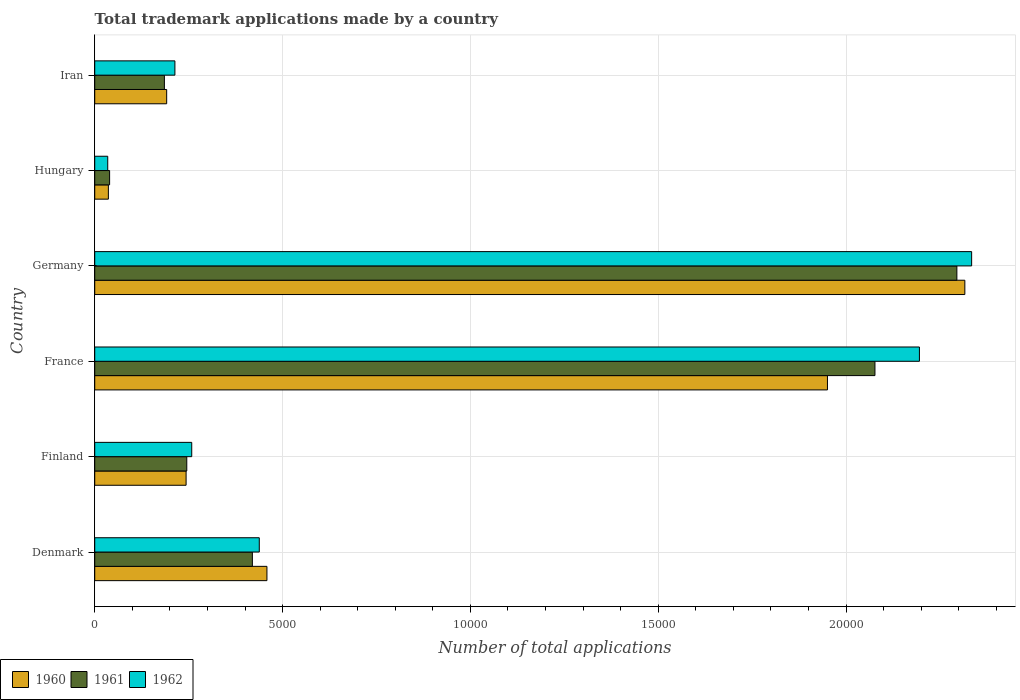How many different coloured bars are there?
Provide a short and direct response. 3. How many groups of bars are there?
Your answer should be compact. 6. Are the number of bars per tick equal to the number of legend labels?
Ensure brevity in your answer.  Yes. Are the number of bars on each tick of the Y-axis equal?
Give a very brief answer. Yes. How many bars are there on the 4th tick from the top?
Your response must be concise. 3. What is the label of the 2nd group of bars from the top?
Give a very brief answer. Hungary. In how many cases, is the number of bars for a given country not equal to the number of legend labels?
Keep it short and to the point. 0. What is the number of applications made by in 1962 in Denmark?
Your answer should be compact. 4380. Across all countries, what is the maximum number of applications made by in 1961?
Your response must be concise. 2.29e+04. Across all countries, what is the minimum number of applications made by in 1960?
Ensure brevity in your answer.  363. In which country was the number of applications made by in 1961 maximum?
Provide a short and direct response. Germany. In which country was the number of applications made by in 1960 minimum?
Keep it short and to the point. Hungary. What is the total number of applications made by in 1961 in the graph?
Provide a succinct answer. 5.26e+04. What is the difference between the number of applications made by in 1960 in Denmark and that in Hungary?
Your answer should be compact. 4221. What is the difference between the number of applications made by in 1961 in Denmark and the number of applications made by in 1962 in Iran?
Provide a succinct answer. 2062. What is the average number of applications made by in 1961 per country?
Make the answer very short. 8768.83. What is the difference between the number of applications made by in 1962 and number of applications made by in 1960 in Iran?
Give a very brief answer. 219. In how many countries, is the number of applications made by in 1961 greater than 19000 ?
Offer a very short reply. 2. What is the ratio of the number of applications made by in 1962 in France to that in Iran?
Keep it short and to the point. 10.29. Is the difference between the number of applications made by in 1962 in France and Iran greater than the difference between the number of applications made by in 1960 in France and Iran?
Give a very brief answer. Yes. What is the difference between the highest and the second highest number of applications made by in 1960?
Your answer should be compact. 3657. What is the difference between the highest and the lowest number of applications made by in 1962?
Keep it short and to the point. 2.30e+04. Is the sum of the number of applications made by in 1962 in France and Hungary greater than the maximum number of applications made by in 1961 across all countries?
Keep it short and to the point. No. What does the 2nd bar from the top in Iran represents?
Your response must be concise. 1961. Are all the bars in the graph horizontal?
Provide a short and direct response. Yes. How many countries are there in the graph?
Keep it short and to the point. 6. What is the difference between two consecutive major ticks on the X-axis?
Your answer should be compact. 5000. Are the values on the major ticks of X-axis written in scientific E-notation?
Keep it short and to the point. No. Does the graph contain grids?
Provide a short and direct response. Yes. How are the legend labels stacked?
Provide a short and direct response. Horizontal. What is the title of the graph?
Provide a succinct answer. Total trademark applications made by a country. Does "2007" appear as one of the legend labels in the graph?
Your answer should be very brief. No. What is the label or title of the X-axis?
Make the answer very short. Number of total applications. What is the Number of total applications in 1960 in Denmark?
Keep it short and to the point. 4584. What is the Number of total applications in 1961 in Denmark?
Give a very brief answer. 4196. What is the Number of total applications in 1962 in Denmark?
Make the answer very short. 4380. What is the Number of total applications in 1960 in Finland?
Offer a terse response. 2432. What is the Number of total applications of 1961 in Finland?
Your response must be concise. 2450. What is the Number of total applications in 1962 in Finland?
Ensure brevity in your answer.  2582. What is the Number of total applications in 1960 in France?
Keep it short and to the point. 1.95e+04. What is the Number of total applications of 1961 in France?
Your answer should be compact. 2.08e+04. What is the Number of total applications in 1962 in France?
Your answer should be very brief. 2.20e+04. What is the Number of total applications in 1960 in Germany?
Keep it short and to the point. 2.32e+04. What is the Number of total applications in 1961 in Germany?
Offer a terse response. 2.29e+04. What is the Number of total applications in 1962 in Germany?
Offer a terse response. 2.33e+04. What is the Number of total applications in 1960 in Hungary?
Provide a short and direct response. 363. What is the Number of total applications in 1961 in Hungary?
Provide a succinct answer. 396. What is the Number of total applications in 1962 in Hungary?
Your response must be concise. 346. What is the Number of total applications of 1960 in Iran?
Your response must be concise. 1915. What is the Number of total applications in 1961 in Iran?
Your answer should be compact. 1854. What is the Number of total applications in 1962 in Iran?
Your response must be concise. 2134. Across all countries, what is the maximum Number of total applications of 1960?
Provide a short and direct response. 2.32e+04. Across all countries, what is the maximum Number of total applications of 1961?
Offer a terse response. 2.29e+04. Across all countries, what is the maximum Number of total applications of 1962?
Keep it short and to the point. 2.33e+04. Across all countries, what is the minimum Number of total applications in 1960?
Your response must be concise. 363. Across all countries, what is the minimum Number of total applications of 1961?
Keep it short and to the point. 396. Across all countries, what is the minimum Number of total applications in 1962?
Offer a very short reply. 346. What is the total Number of total applications in 1960 in the graph?
Offer a terse response. 5.20e+04. What is the total Number of total applications in 1961 in the graph?
Offer a very short reply. 5.26e+04. What is the total Number of total applications of 1962 in the graph?
Your response must be concise. 5.47e+04. What is the difference between the Number of total applications in 1960 in Denmark and that in Finland?
Make the answer very short. 2152. What is the difference between the Number of total applications of 1961 in Denmark and that in Finland?
Keep it short and to the point. 1746. What is the difference between the Number of total applications of 1962 in Denmark and that in Finland?
Your answer should be compact. 1798. What is the difference between the Number of total applications of 1960 in Denmark and that in France?
Your answer should be compact. -1.49e+04. What is the difference between the Number of total applications in 1961 in Denmark and that in France?
Give a very brief answer. -1.66e+04. What is the difference between the Number of total applications in 1962 in Denmark and that in France?
Offer a terse response. -1.76e+04. What is the difference between the Number of total applications in 1960 in Denmark and that in Germany?
Give a very brief answer. -1.86e+04. What is the difference between the Number of total applications in 1961 in Denmark and that in Germany?
Ensure brevity in your answer.  -1.88e+04. What is the difference between the Number of total applications of 1962 in Denmark and that in Germany?
Provide a short and direct response. -1.90e+04. What is the difference between the Number of total applications in 1960 in Denmark and that in Hungary?
Offer a very short reply. 4221. What is the difference between the Number of total applications of 1961 in Denmark and that in Hungary?
Your answer should be very brief. 3800. What is the difference between the Number of total applications in 1962 in Denmark and that in Hungary?
Your response must be concise. 4034. What is the difference between the Number of total applications of 1960 in Denmark and that in Iran?
Your answer should be very brief. 2669. What is the difference between the Number of total applications of 1961 in Denmark and that in Iran?
Keep it short and to the point. 2342. What is the difference between the Number of total applications of 1962 in Denmark and that in Iran?
Provide a short and direct response. 2246. What is the difference between the Number of total applications of 1960 in Finland and that in France?
Make the answer very short. -1.71e+04. What is the difference between the Number of total applications of 1961 in Finland and that in France?
Ensure brevity in your answer.  -1.83e+04. What is the difference between the Number of total applications in 1962 in Finland and that in France?
Make the answer very short. -1.94e+04. What is the difference between the Number of total applications in 1960 in Finland and that in Germany?
Keep it short and to the point. -2.07e+04. What is the difference between the Number of total applications of 1961 in Finland and that in Germany?
Your response must be concise. -2.05e+04. What is the difference between the Number of total applications in 1962 in Finland and that in Germany?
Provide a succinct answer. -2.08e+04. What is the difference between the Number of total applications in 1960 in Finland and that in Hungary?
Provide a succinct answer. 2069. What is the difference between the Number of total applications of 1961 in Finland and that in Hungary?
Make the answer very short. 2054. What is the difference between the Number of total applications of 1962 in Finland and that in Hungary?
Make the answer very short. 2236. What is the difference between the Number of total applications of 1960 in Finland and that in Iran?
Make the answer very short. 517. What is the difference between the Number of total applications in 1961 in Finland and that in Iran?
Offer a very short reply. 596. What is the difference between the Number of total applications of 1962 in Finland and that in Iran?
Keep it short and to the point. 448. What is the difference between the Number of total applications in 1960 in France and that in Germany?
Give a very brief answer. -3657. What is the difference between the Number of total applications in 1961 in France and that in Germany?
Provide a short and direct response. -2181. What is the difference between the Number of total applications in 1962 in France and that in Germany?
Keep it short and to the point. -1390. What is the difference between the Number of total applications of 1960 in France and that in Hungary?
Offer a very short reply. 1.91e+04. What is the difference between the Number of total applications in 1961 in France and that in Hungary?
Your answer should be very brief. 2.04e+04. What is the difference between the Number of total applications of 1962 in France and that in Hungary?
Make the answer very short. 2.16e+04. What is the difference between the Number of total applications of 1960 in France and that in Iran?
Ensure brevity in your answer.  1.76e+04. What is the difference between the Number of total applications of 1961 in France and that in Iran?
Your response must be concise. 1.89e+04. What is the difference between the Number of total applications of 1962 in France and that in Iran?
Your response must be concise. 1.98e+04. What is the difference between the Number of total applications of 1960 in Germany and that in Hungary?
Make the answer very short. 2.28e+04. What is the difference between the Number of total applications of 1961 in Germany and that in Hungary?
Your answer should be compact. 2.26e+04. What is the difference between the Number of total applications in 1962 in Germany and that in Hungary?
Keep it short and to the point. 2.30e+04. What is the difference between the Number of total applications of 1960 in Germany and that in Iran?
Keep it short and to the point. 2.12e+04. What is the difference between the Number of total applications of 1961 in Germany and that in Iran?
Offer a terse response. 2.11e+04. What is the difference between the Number of total applications in 1962 in Germany and that in Iran?
Offer a terse response. 2.12e+04. What is the difference between the Number of total applications of 1960 in Hungary and that in Iran?
Keep it short and to the point. -1552. What is the difference between the Number of total applications of 1961 in Hungary and that in Iran?
Your answer should be compact. -1458. What is the difference between the Number of total applications in 1962 in Hungary and that in Iran?
Your response must be concise. -1788. What is the difference between the Number of total applications in 1960 in Denmark and the Number of total applications in 1961 in Finland?
Offer a very short reply. 2134. What is the difference between the Number of total applications in 1960 in Denmark and the Number of total applications in 1962 in Finland?
Make the answer very short. 2002. What is the difference between the Number of total applications in 1961 in Denmark and the Number of total applications in 1962 in Finland?
Make the answer very short. 1614. What is the difference between the Number of total applications in 1960 in Denmark and the Number of total applications in 1961 in France?
Ensure brevity in your answer.  -1.62e+04. What is the difference between the Number of total applications of 1960 in Denmark and the Number of total applications of 1962 in France?
Offer a very short reply. -1.74e+04. What is the difference between the Number of total applications in 1961 in Denmark and the Number of total applications in 1962 in France?
Your response must be concise. -1.78e+04. What is the difference between the Number of total applications of 1960 in Denmark and the Number of total applications of 1961 in Germany?
Ensure brevity in your answer.  -1.84e+04. What is the difference between the Number of total applications of 1960 in Denmark and the Number of total applications of 1962 in Germany?
Your answer should be very brief. -1.88e+04. What is the difference between the Number of total applications of 1961 in Denmark and the Number of total applications of 1962 in Germany?
Provide a succinct answer. -1.91e+04. What is the difference between the Number of total applications of 1960 in Denmark and the Number of total applications of 1961 in Hungary?
Provide a succinct answer. 4188. What is the difference between the Number of total applications in 1960 in Denmark and the Number of total applications in 1962 in Hungary?
Your response must be concise. 4238. What is the difference between the Number of total applications of 1961 in Denmark and the Number of total applications of 1962 in Hungary?
Ensure brevity in your answer.  3850. What is the difference between the Number of total applications of 1960 in Denmark and the Number of total applications of 1961 in Iran?
Offer a terse response. 2730. What is the difference between the Number of total applications of 1960 in Denmark and the Number of total applications of 1962 in Iran?
Your answer should be compact. 2450. What is the difference between the Number of total applications in 1961 in Denmark and the Number of total applications in 1962 in Iran?
Provide a short and direct response. 2062. What is the difference between the Number of total applications in 1960 in Finland and the Number of total applications in 1961 in France?
Your answer should be very brief. -1.83e+04. What is the difference between the Number of total applications of 1960 in Finland and the Number of total applications of 1962 in France?
Your answer should be compact. -1.95e+04. What is the difference between the Number of total applications in 1961 in Finland and the Number of total applications in 1962 in France?
Offer a terse response. -1.95e+04. What is the difference between the Number of total applications in 1960 in Finland and the Number of total applications in 1961 in Germany?
Offer a terse response. -2.05e+04. What is the difference between the Number of total applications in 1960 in Finland and the Number of total applications in 1962 in Germany?
Provide a succinct answer. -2.09e+04. What is the difference between the Number of total applications in 1961 in Finland and the Number of total applications in 1962 in Germany?
Make the answer very short. -2.09e+04. What is the difference between the Number of total applications in 1960 in Finland and the Number of total applications in 1961 in Hungary?
Offer a very short reply. 2036. What is the difference between the Number of total applications in 1960 in Finland and the Number of total applications in 1962 in Hungary?
Give a very brief answer. 2086. What is the difference between the Number of total applications of 1961 in Finland and the Number of total applications of 1962 in Hungary?
Provide a succinct answer. 2104. What is the difference between the Number of total applications of 1960 in Finland and the Number of total applications of 1961 in Iran?
Offer a very short reply. 578. What is the difference between the Number of total applications in 1960 in Finland and the Number of total applications in 1962 in Iran?
Your response must be concise. 298. What is the difference between the Number of total applications in 1961 in Finland and the Number of total applications in 1962 in Iran?
Offer a terse response. 316. What is the difference between the Number of total applications of 1960 in France and the Number of total applications of 1961 in Germany?
Offer a terse response. -3445. What is the difference between the Number of total applications in 1960 in France and the Number of total applications in 1962 in Germany?
Keep it short and to the point. -3838. What is the difference between the Number of total applications in 1961 in France and the Number of total applications in 1962 in Germany?
Give a very brief answer. -2574. What is the difference between the Number of total applications in 1960 in France and the Number of total applications in 1961 in Hungary?
Offer a very short reply. 1.91e+04. What is the difference between the Number of total applications of 1960 in France and the Number of total applications of 1962 in Hungary?
Your response must be concise. 1.92e+04. What is the difference between the Number of total applications of 1961 in France and the Number of total applications of 1962 in Hungary?
Offer a very short reply. 2.04e+04. What is the difference between the Number of total applications in 1960 in France and the Number of total applications in 1961 in Iran?
Make the answer very short. 1.76e+04. What is the difference between the Number of total applications in 1960 in France and the Number of total applications in 1962 in Iran?
Keep it short and to the point. 1.74e+04. What is the difference between the Number of total applications of 1961 in France and the Number of total applications of 1962 in Iran?
Give a very brief answer. 1.86e+04. What is the difference between the Number of total applications of 1960 in Germany and the Number of total applications of 1961 in Hungary?
Provide a short and direct response. 2.28e+04. What is the difference between the Number of total applications of 1960 in Germany and the Number of total applications of 1962 in Hungary?
Your response must be concise. 2.28e+04. What is the difference between the Number of total applications in 1961 in Germany and the Number of total applications in 1962 in Hungary?
Provide a short and direct response. 2.26e+04. What is the difference between the Number of total applications of 1960 in Germany and the Number of total applications of 1961 in Iran?
Your answer should be compact. 2.13e+04. What is the difference between the Number of total applications of 1960 in Germany and the Number of total applications of 1962 in Iran?
Provide a short and direct response. 2.10e+04. What is the difference between the Number of total applications of 1961 in Germany and the Number of total applications of 1962 in Iran?
Your answer should be compact. 2.08e+04. What is the difference between the Number of total applications in 1960 in Hungary and the Number of total applications in 1961 in Iran?
Provide a succinct answer. -1491. What is the difference between the Number of total applications of 1960 in Hungary and the Number of total applications of 1962 in Iran?
Provide a short and direct response. -1771. What is the difference between the Number of total applications of 1961 in Hungary and the Number of total applications of 1962 in Iran?
Provide a succinct answer. -1738. What is the average Number of total applications in 1960 per country?
Your answer should be very brief. 8659.83. What is the average Number of total applications of 1961 per country?
Provide a short and direct response. 8768.83. What is the average Number of total applications in 1962 per country?
Give a very brief answer. 9122.67. What is the difference between the Number of total applications in 1960 and Number of total applications in 1961 in Denmark?
Offer a terse response. 388. What is the difference between the Number of total applications of 1960 and Number of total applications of 1962 in Denmark?
Your response must be concise. 204. What is the difference between the Number of total applications in 1961 and Number of total applications in 1962 in Denmark?
Offer a very short reply. -184. What is the difference between the Number of total applications of 1960 and Number of total applications of 1962 in Finland?
Your answer should be very brief. -150. What is the difference between the Number of total applications of 1961 and Number of total applications of 1962 in Finland?
Offer a terse response. -132. What is the difference between the Number of total applications of 1960 and Number of total applications of 1961 in France?
Your answer should be very brief. -1264. What is the difference between the Number of total applications of 1960 and Number of total applications of 1962 in France?
Your response must be concise. -2448. What is the difference between the Number of total applications in 1961 and Number of total applications in 1962 in France?
Offer a very short reply. -1184. What is the difference between the Number of total applications in 1960 and Number of total applications in 1961 in Germany?
Ensure brevity in your answer.  212. What is the difference between the Number of total applications in 1960 and Number of total applications in 1962 in Germany?
Give a very brief answer. -181. What is the difference between the Number of total applications of 1961 and Number of total applications of 1962 in Germany?
Provide a succinct answer. -393. What is the difference between the Number of total applications in 1960 and Number of total applications in 1961 in Hungary?
Offer a very short reply. -33. What is the difference between the Number of total applications of 1960 and Number of total applications of 1962 in Iran?
Your response must be concise. -219. What is the difference between the Number of total applications in 1961 and Number of total applications in 1962 in Iran?
Make the answer very short. -280. What is the ratio of the Number of total applications of 1960 in Denmark to that in Finland?
Keep it short and to the point. 1.88. What is the ratio of the Number of total applications in 1961 in Denmark to that in Finland?
Offer a very short reply. 1.71. What is the ratio of the Number of total applications in 1962 in Denmark to that in Finland?
Offer a very short reply. 1.7. What is the ratio of the Number of total applications in 1960 in Denmark to that in France?
Ensure brevity in your answer.  0.23. What is the ratio of the Number of total applications in 1961 in Denmark to that in France?
Your answer should be compact. 0.2. What is the ratio of the Number of total applications in 1962 in Denmark to that in France?
Offer a very short reply. 0.2. What is the ratio of the Number of total applications of 1960 in Denmark to that in Germany?
Provide a succinct answer. 0.2. What is the ratio of the Number of total applications in 1961 in Denmark to that in Germany?
Offer a terse response. 0.18. What is the ratio of the Number of total applications of 1962 in Denmark to that in Germany?
Your answer should be compact. 0.19. What is the ratio of the Number of total applications of 1960 in Denmark to that in Hungary?
Offer a very short reply. 12.63. What is the ratio of the Number of total applications of 1961 in Denmark to that in Hungary?
Provide a succinct answer. 10.6. What is the ratio of the Number of total applications of 1962 in Denmark to that in Hungary?
Keep it short and to the point. 12.66. What is the ratio of the Number of total applications in 1960 in Denmark to that in Iran?
Give a very brief answer. 2.39. What is the ratio of the Number of total applications of 1961 in Denmark to that in Iran?
Keep it short and to the point. 2.26. What is the ratio of the Number of total applications in 1962 in Denmark to that in Iran?
Ensure brevity in your answer.  2.05. What is the ratio of the Number of total applications in 1960 in Finland to that in France?
Provide a succinct answer. 0.12. What is the ratio of the Number of total applications of 1961 in Finland to that in France?
Your answer should be compact. 0.12. What is the ratio of the Number of total applications of 1962 in Finland to that in France?
Make the answer very short. 0.12. What is the ratio of the Number of total applications of 1960 in Finland to that in Germany?
Offer a terse response. 0.1. What is the ratio of the Number of total applications in 1961 in Finland to that in Germany?
Ensure brevity in your answer.  0.11. What is the ratio of the Number of total applications in 1962 in Finland to that in Germany?
Provide a succinct answer. 0.11. What is the ratio of the Number of total applications of 1960 in Finland to that in Hungary?
Provide a succinct answer. 6.7. What is the ratio of the Number of total applications in 1961 in Finland to that in Hungary?
Make the answer very short. 6.19. What is the ratio of the Number of total applications in 1962 in Finland to that in Hungary?
Keep it short and to the point. 7.46. What is the ratio of the Number of total applications in 1960 in Finland to that in Iran?
Provide a succinct answer. 1.27. What is the ratio of the Number of total applications of 1961 in Finland to that in Iran?
Offer a terse response. 1.32. What is the ratio of the Number of total applications of 1962 in Finland to that in Iran?
Give a very brief answer. 1.21. What is the ratio of the Number of total applications of 1960 in France to that in Germany?
Your response must be concise. 0.84. What is the ratio of the Number of total applications of 1961 in France to that in Germany?
Offer a very short reply. 0.91. What is the ratio of the Number of total applications of 1962 in France to that in Germany?
Make the answer very short. 0.94. What is the ratio of the Number of total applications in 1960 in France to that in Hungary?
Keep it short and to the point. 53.73. What is the ratio of the Number of total applications in 1961 in France to that in Hungary?
Your answer should be very brief. 52.44. What is the ratio of the Number of total applications in 1962 in France to that in Hungary?
Offer a terse response. 63.45. What is the ratio of the Number of total applications in 1960 in France to that in Iran?
Your answer should be compact. 10.18. What is the ratio of the Number of total applications of 1961 in France to that in Iran?
Offer a terse response. 11.2. What is the ratio of the Number of total applications of 1962 in France to that in Iran?
Offer a terse response. 10.29. What is the ratio of the Number of total applications in 1960 in Germany to that in Hungary?
Offer a very short reply. 63.8. What is the ratio of the Number of total applications of 1961 in Germany to that in Hungary?
Offer a very short reply. 57.95. What is the ratio of the Number of total applications in 1962 in Germany to that in Hungary?
Your answer should be compact. 67.46. What is the ratio of the Number of total applications in 1960 in Germany to that in Iran?
Ensure brevity in your answer.  12.09. What is the ratio of the Number of total applications of 1961 in Germany to that in Iran?
Provide a short and direct response. 12.38. What is the ratio of the Number of total applications of 1962 in Germany to that in Iran?
Give a very brief answer. 10.94. What is the ratio of the Number of total applications of 1960 in Hungary to that in Iran?
Provide a short and direct response. 0.19. What is the ratio of the Number of total applications of 1961 in Hungary to that in Iran?
Provide a short and direct response. 0.21. What is the ratio of the Number of total applications of 1962 in Hungary to that in Iran?
Your answer should be very brief. 0.16. What is the difference between the highest and the second highest Number of total applications of 1960?
Provide a succinct answer. 3657. What is the difference between the highest and the second highest Number of total applications of 1961?
Give a very brief answer. 2181. What is the difference between the highest and the second highest Number of total applications in 1962?
Keep it short and to the point. 1390. What is the difference between the highest and the lowest Number of total applications of 1960?
Your answer should be very brief. 2.28e+04. What is the difference between the highest and the lowest Number of total applications of 1961?
Keep it short and to the point. 2.26e+04. What is the difference between the highest and the lowest Number of total applications of 1962?
Provide a succinct answer. 2.30e+04. 